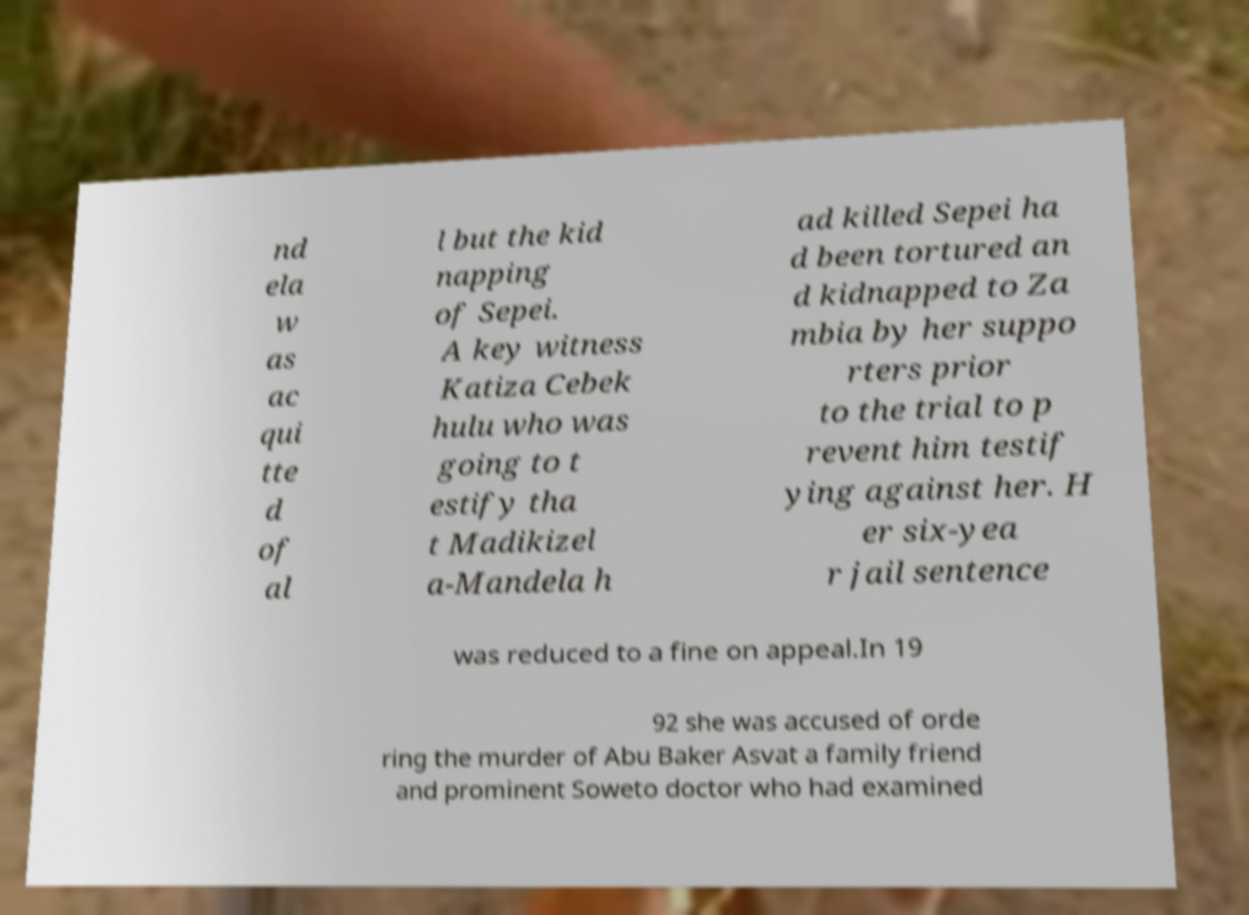Could you assist in decoding the text presented in this image and type it out clearly? nd ela w as ac qui tte d of al l but the kid napping of Sepei. A key witness Katiza Cebek hulu who was going to t estify tha t Madikizel a-Mandela h ad killed Sepei ha d been tortured an d kidnapped to Za mbia by her suppo rters prior to the trial to p revent him testif ying against her. H er six-yea r jail sentence was reduced to a fine on appeal.In 19 92 she was accused of orde ring the murder of Abu Baker Asvat a family friend and prominent Soweto doctor who had examined 